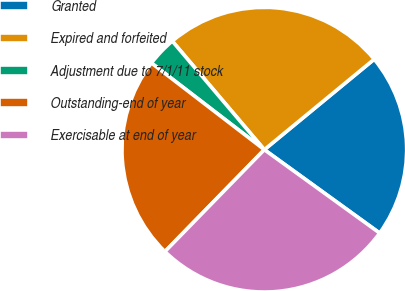Convert chart. <chart><loc_0><loc_0><loc_500><loc_500><pie_chart><fcel>Granted<fcel>Expired and forfeited<fcel>Adjustment due to 7/1/11 stock<fcel>Outstanding-end of year<fcel>Exercisable at end of year<nl><fcel>20.93%<fcel>25.23%<fcel>3.39%<fcel>23.12%<fcel>27.34%<nl></chart> 